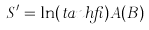<formula> <loc_0><loc_0><loc_500><loc_500>S ^ { \prime } = \ln ( t a n h \beta ) A ( B )</formula> 